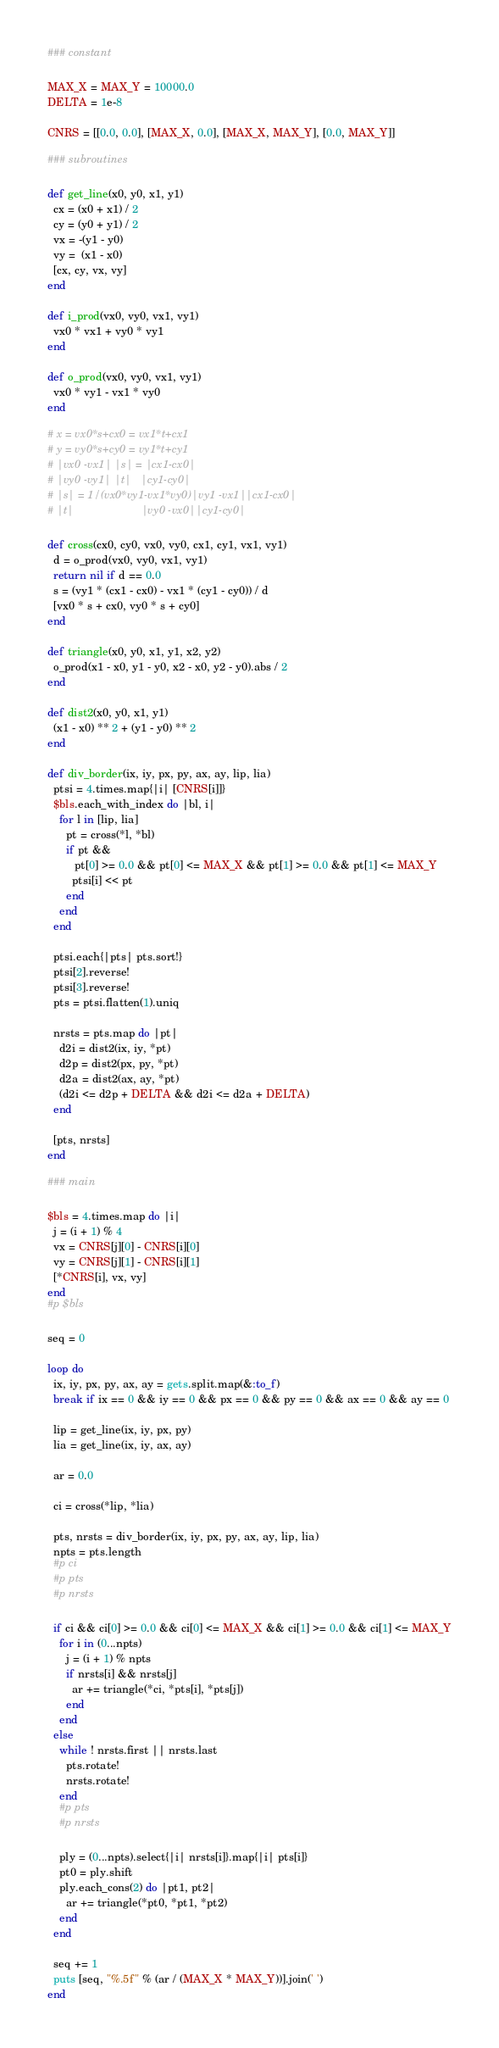<code> <loc_0><loc_0><loc_500><loc_500><_Ruby_>### constant

MAX_X = MAX_Y = 10000.0
DELTA = 1e-8

CNRS = [[0.0, 0.0], [MAX_X, 0.0], [MAX_X, MAX_Y], [0.0, MAX_Y]]

### subroutines

def get_line(x0, y0, x1, y1)
  cx = (x0 + x1) / 2
  cy = (y0 + y1) / 2
  vx = -(y1 - y0)
  vy =  (x1 - x0)
  [cx, cy, vx, vy]
end

def i_prod(vx0, vy0, vx1, vy1)
  vx0 * vx1 + vy0 * vy1
end

def o_prod(vx0, vy0, vx1, vy1)
  vx0 * vy1 - vx1 * vy0
end

# x = vx0*s+cx0 = vx1*t+cx1
# y = vy0*s+cy0 = vy1*t+cy1
# |vx0 -vx1| |s| = |cx1-cx0|
# |vy0 -vy1| |t|   |cy1-cy0|
# |s| = 1/(vx0*vy1-vx1*vy0)|vy1 -vx1||cx1-cx0|
# |t|                      |vy0 -vx0||cy1-cy0|

def cross(cx0, cy0, vx0, vy0, cx1, cy1, vx1, vy1)
  d = o_prod(vx0, vy0, vx1, vy1)
  return nil if d == 0.0
  s = (vy1 * (cx1 - cx0) - vx1 * (cy1 - cy0)) / d
  [vx0 * s + cx0, vy0 * s + cy0]
end

def triangle(x0, y0, x1, y1, x2, y2)
  o_prod(x1 - x0, y1 - y0, x2 - x0, y2 - y0).abs / 2
end

def dist2(x0, y0, x1, y1)
  (x1 - x0) ** 2 + (y1 - y0) ** 2
end

def div_border(ix, iy, px, py, ax, ay, lip, lia)
  ptsi = 4.times.map{|i| [CNRS[i]]}
  $bls.each_with_index do |bl, i|
    for l in [lip, lia]
      pt = cross(*l, *bl)
      if pt &&
         pt[0] >= 0.0 && pt[0] <= MAX_X && pt[1] >= 0.0 && pt[1] <= MAX_Y
        ptsi[i] << pt
      end
    end
  end

  ptsi.each{|pts| pts.sort!}
  ptsi[2].reverse!
  ptsi[3].reverse!
  pts = ptsi.flatten(1).uniq

  nrsts = pts.map do |pt|
    d2i = dist2(ix, iy, *pt)
    d2p = dist2(px, py, *pt)
    d2a = dist2(ax, ay, *pt)
    (d2i <= d2p + DELTA && d2i <= d2a + DELTA)
  end

  [pts, nrsts]
end

### main

$bls = 4.times.map do |i|
  j = (i + 1) % 4
  vx = CNRS[j][0] - CNRS[i][0]
  vy = CNRS[j][1] - CNRS[i][1]
  [*CNRS[i], vx, vy]
end
#p $bls

seq = 0

loop do
  ix, iy, px, py, ax, ay = gets.split.map(&:to_f)
  break if ix == 0 && iy == 0 && px == 0 && py == 0 && ax == 0 && ay == 0

  lip = get_line(ix, iy, px, py)
  lia = get_line(ix, iy, ax, ay)

  ar = 0.0
  
  ci = cross(*lip, *lia)

  pts, nrsts = div_border(ix, iy, px, py, ax, ay, lip, lia)
  npts = pts.length
  #p ci
  #p pts
  #p nrsts
  
  if ci && ci[0] >= 0.0 && ci[0] <= MAX_X && ci[1] >= 0.0 && ci[1] <= MAX_Y
    for i in (0...npts)
      j = (i + 1) % npts
      if nrsts[i] && nrsts[j]
        ar += triangle(*ci, *pts[i], *pts[j])
      end
    end
  else
    while ! nrsts.first || nrsts.last
      pts.rotate!
      nrsts.rotate!
    end
    #p pts
    #p nrsts

    ply = (0...npts).select{|i| nrsts[i]}.map{|i| pts[i]}
    pt0 = ply.shift
    ply.each_cons(2) do |pt1, pt2|
      ar += triangle(*pt0, *pt1, *pt2)
    end
  end

  seq += 1
  puts [seq, "%.5f" % (ar / (MAX_X * MAX_Y))].join(' ')
end</code> 